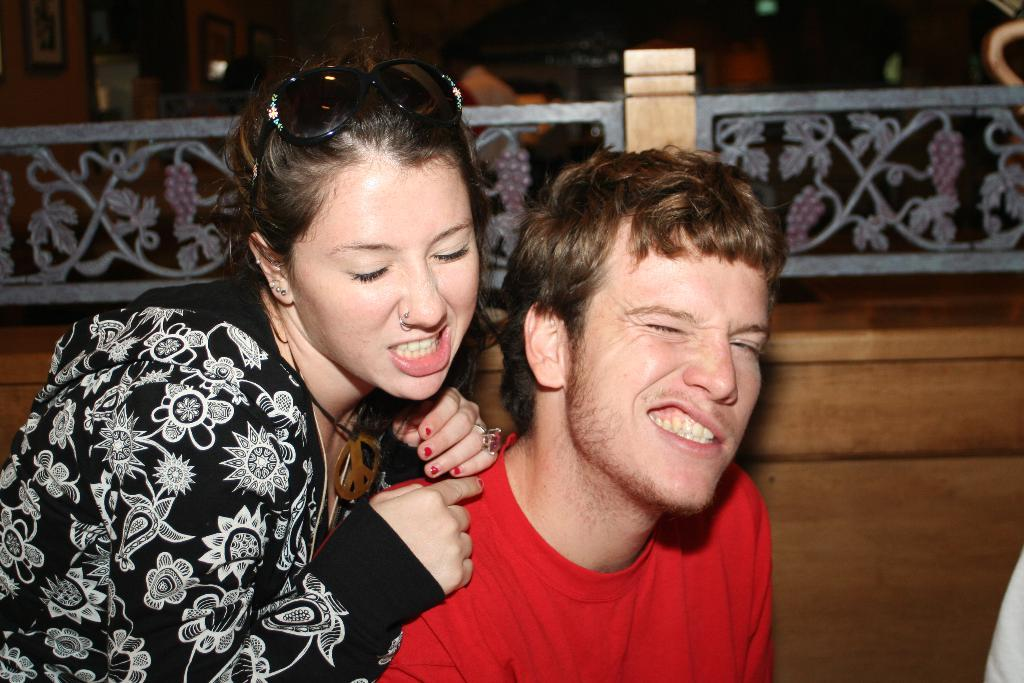How many people are in the image? There is a woman and a man in the image. What can be seen in the background of the image? There is a rail and photo frames on the wall in the background of the image. What type of insect is crawling on the woman's shoulder in the image? There is no insect present on the woman's shoulder in the image. 